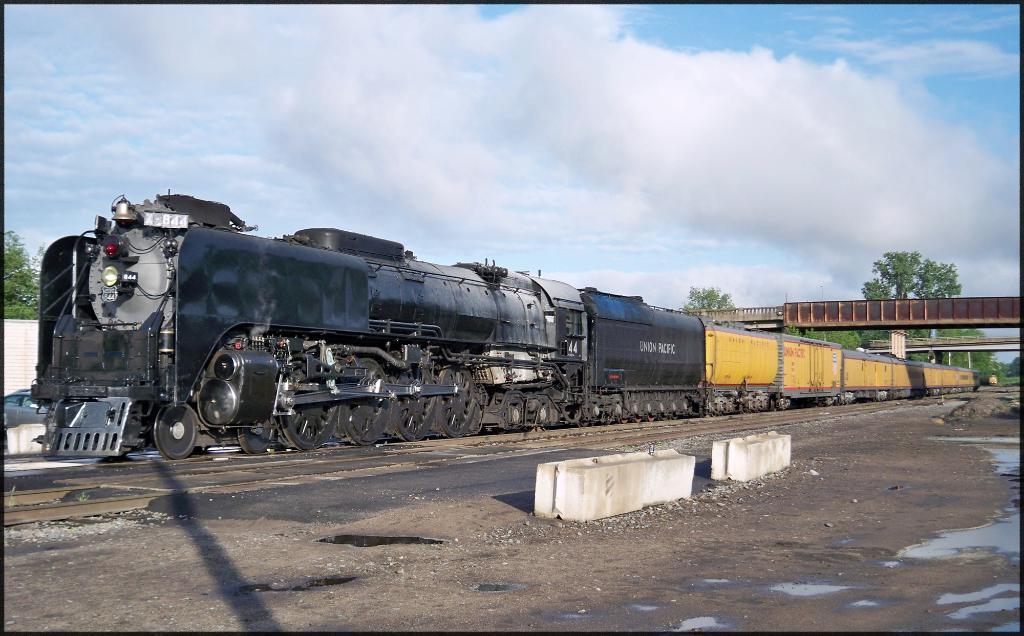Please provide a concise description of this image. In this picture, we see a train in black and yellow color is moving on the tracks. At the bottom, we see the road. We even see the concrete blocks. On the right side, we see the bridges. There are trees in the background. At the top, we see the sky and the clouds. 